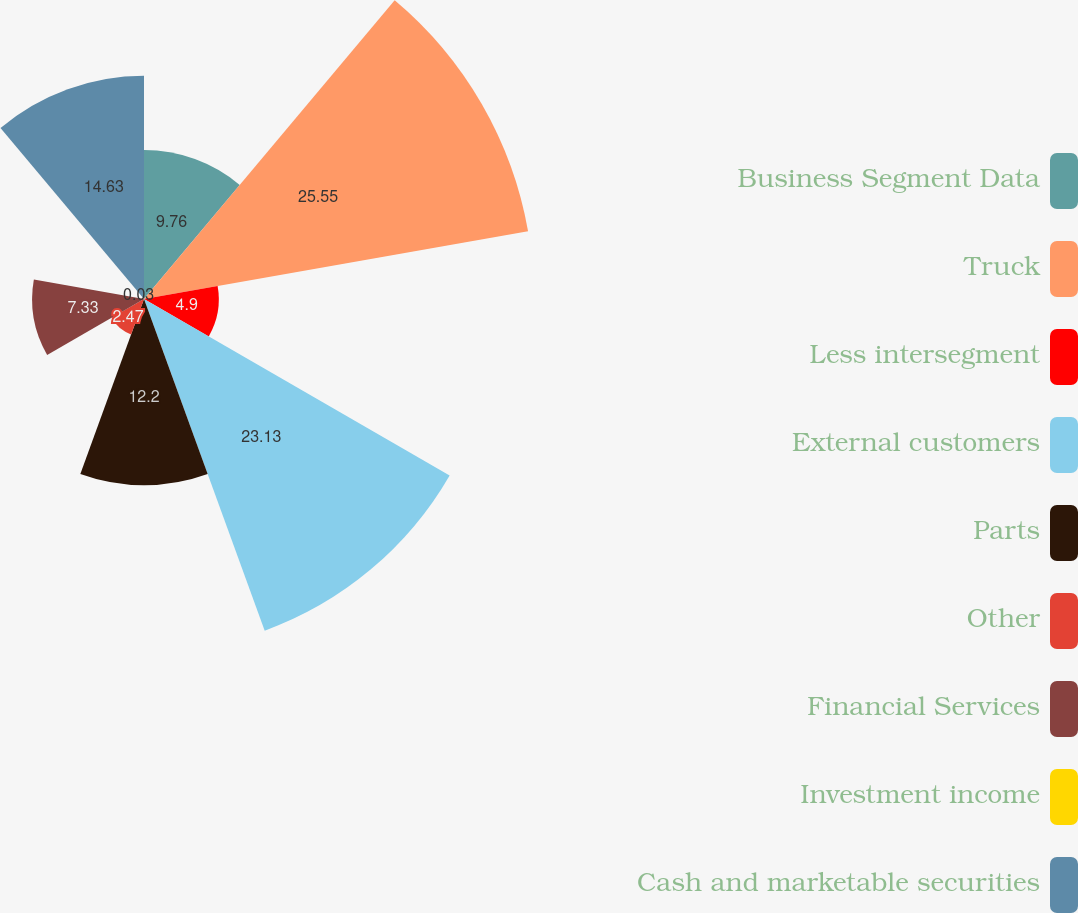Convert chart. <chart><loc_0><loc_0><loc_500><loc_500><pie_chart><fcel>Business Segment Data<fcel>Truck<fcel>Less intersegment<fcel>External customers<fcel>Parts<fcel>Other<fcel>Financial Services<fcel>Investment income<fcel>Cash and marketable securities<nl><fcel>9.76%<fcel>25.56%<fcel>4.9%<fcel>23.13%<fcel>12.2%<fcel>2.47%<fcel>7.33%<fcel>0.03%<fcel>14.63%<nl></chart> 